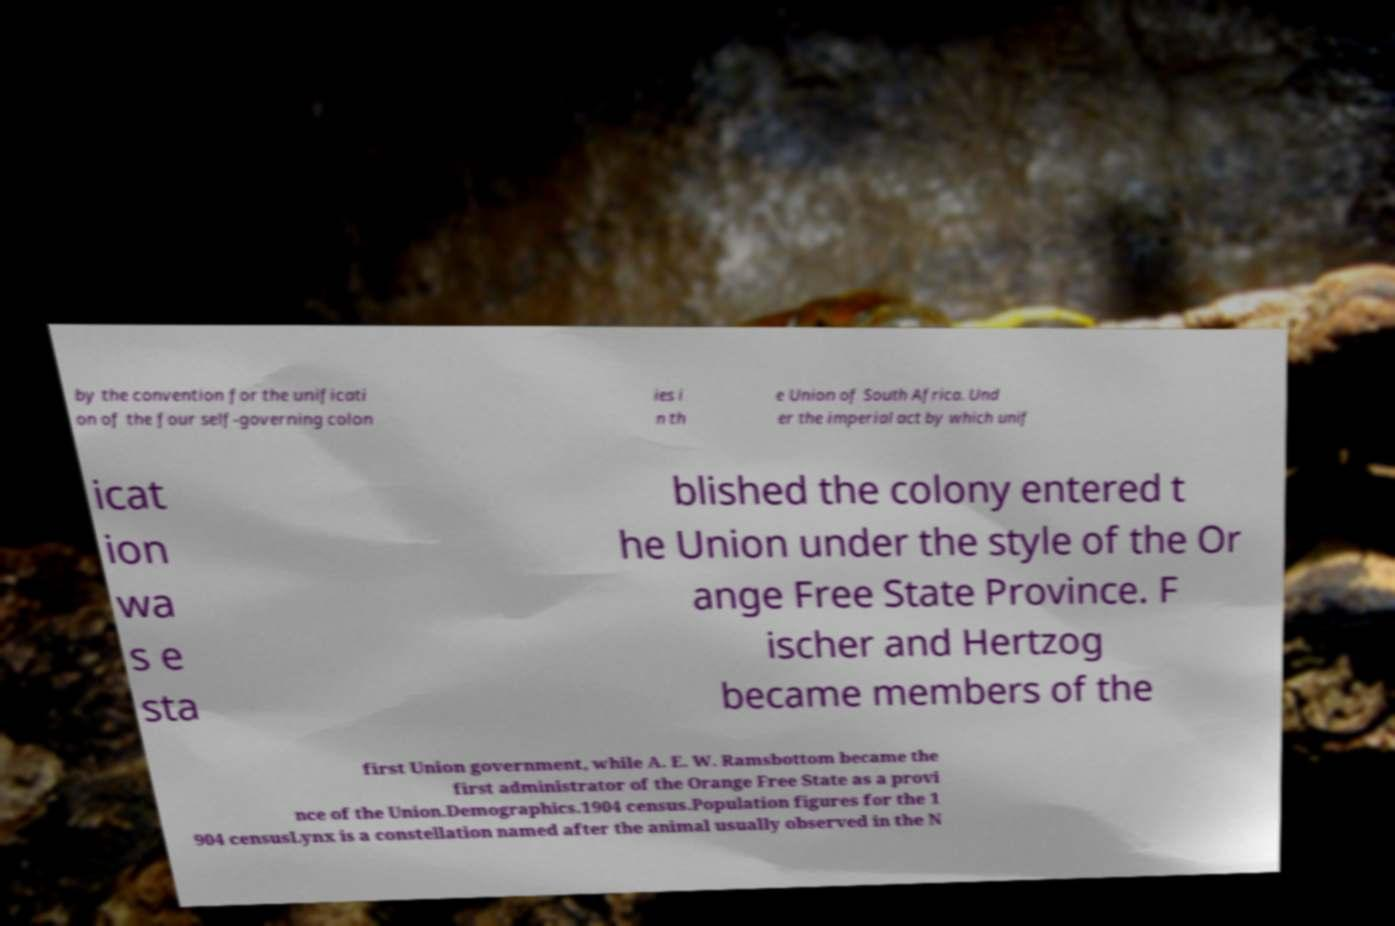There's text embedded in this image that I need extracted. Can you transcribe it verbatim? by the convention for the unificati on of the four self-governing colon ies i n th e Union of South Africa. Und er the imperial act by which unif icat ion wa s e sta blished the colony entered t he Union under the style of the Or ange Free State Province. F ischer and Hertzog became members of the first Union government, while A. E. W. Ramsbottom became the first administrator of the Orange Free State as a provi nce of the Union.Demographics.1904 census.Population figures for the 1 904 censusLynx is a constellation named after the animal usually observed in the N 